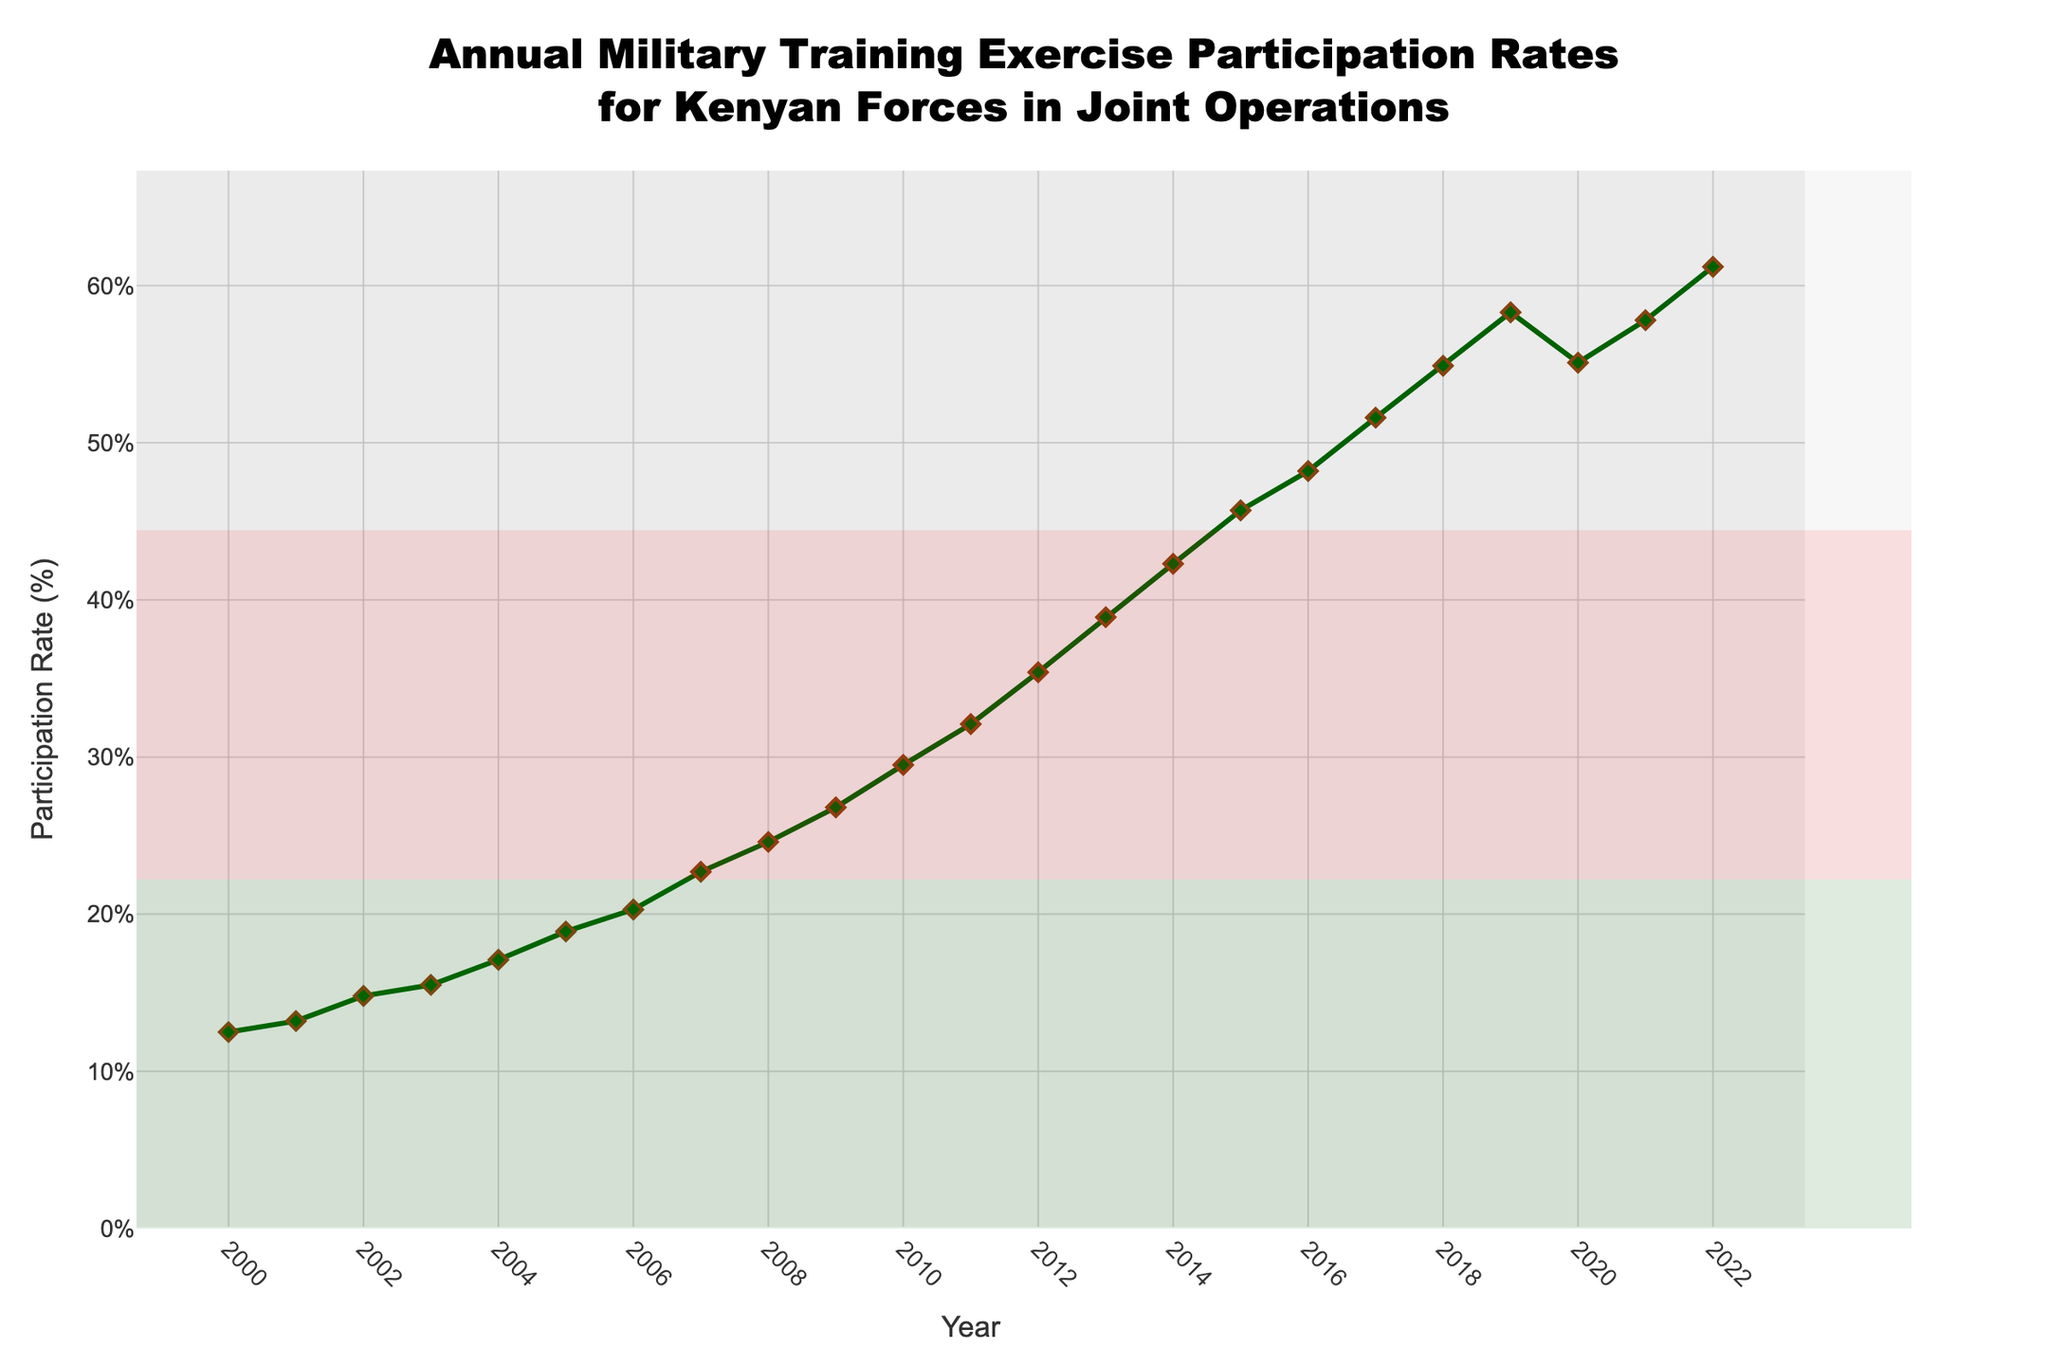What was the participation rate in 2010? The participation rate for 2010 can be seen on the y-axis corresponding to the x-axis value of 2010.
Answer: 29.5% What was the average participation rate from 2000 to 2005? To find the average, sum the participation rates from 2000 to 2005 (12.5 + 13.2 + 14.8 + 15.5 + 17.1 + 18.9 = 92) and divide by the number of years (6).
Answer: 15.33% In which year did the participation rate first exceed 50%? By observing the trend, we see that the participation rate first exceeds 50% in the year 2017.
Answer: 2017 Which year experienced a drop in the participation rate compared to the previous year? By checking each year in sequence, we can see that 2020 had a lower participation rate (55.1%) compared to 2019 (58.3%).
Answer: 2020 By how much did the participation rate increase from 2005 to 2015? Calculate the difference between the rates for 2015 (45.7%) and 2005 (18.9%). The increase is 45.7 - 18.9.
Answer: 26.8% What is the overall trend of the participation rates from 2000 to 2022? From 2000 to 2022, the participation rate generally increases, with a minor dip around 2020.
Answer: Increasing trend What was the percentage increase in participation rate from 2011 to 2012? The rates were 32.1% in 2011 and 35.4% in 2012. The percentage increase is ((35.4 - 32.1) / 32.1) * 100.
Answer: 10.28% Which year had the highest participation rate, and what was the rate? By observing the highest point on the y-axis, the year 2022 had the highest rate at 61.2%.
Answer: 2022 & 61.2% Which two consecutive years had the greatest increase in participation rate? By comparing the differences year-by-year, the greatest increase is observed between 2018 (54.9%) and 2019 (58.3%).
Answer: 2018 and 2019 How did the participation rate change over the period from 2018 to 2021? The participation rate increased from 54.9% in 2018 to 57.8% in 2021, with a slight dip in 2020.
Answer: Increased with a slight dip in 2020 